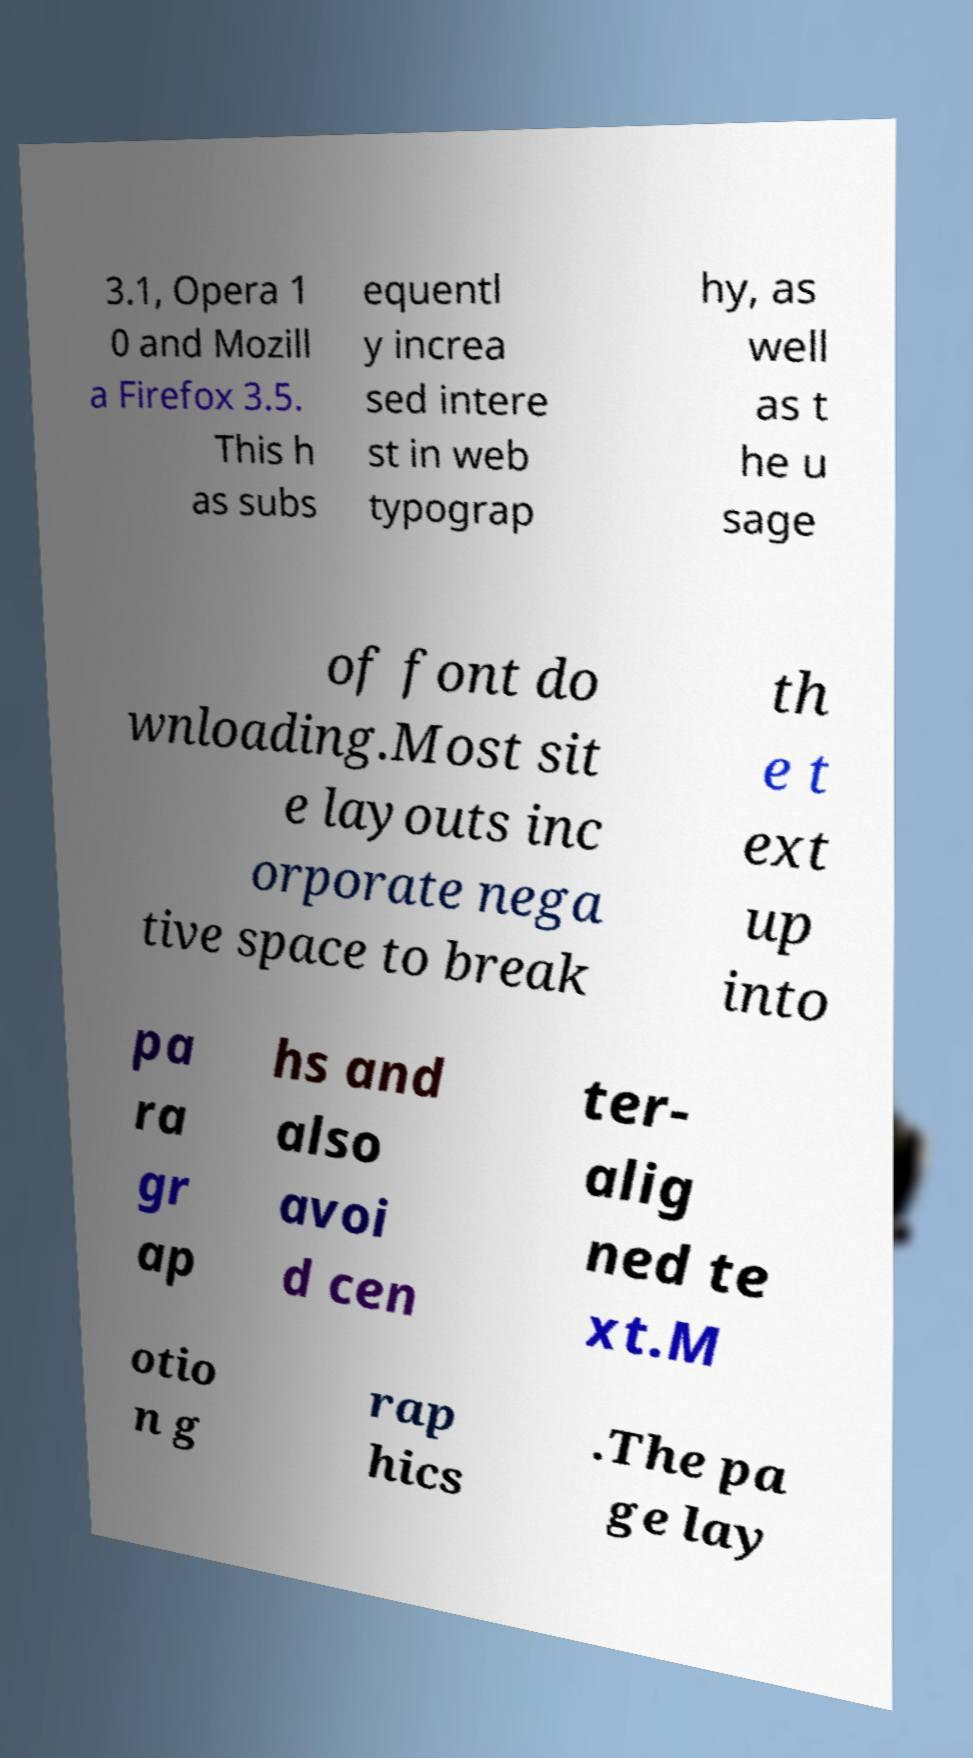Can you read and provide the text displayed in the image?This photo seems to have some interesting text. Can you extract and type it out for me? 3.1, Opera 1 0 and Mozill a Firefox 3.5. This h as subs equentl y increa sed intere st in web typograp hy, as well as t he u sage of font do wnloading.Most sit e layouts inc orporate nega tive space to break th e t ext up into pa ra gr ap hs and also avoi d cen ter- alig ned te xt.M otio n g rap hics .The pa ge lay 